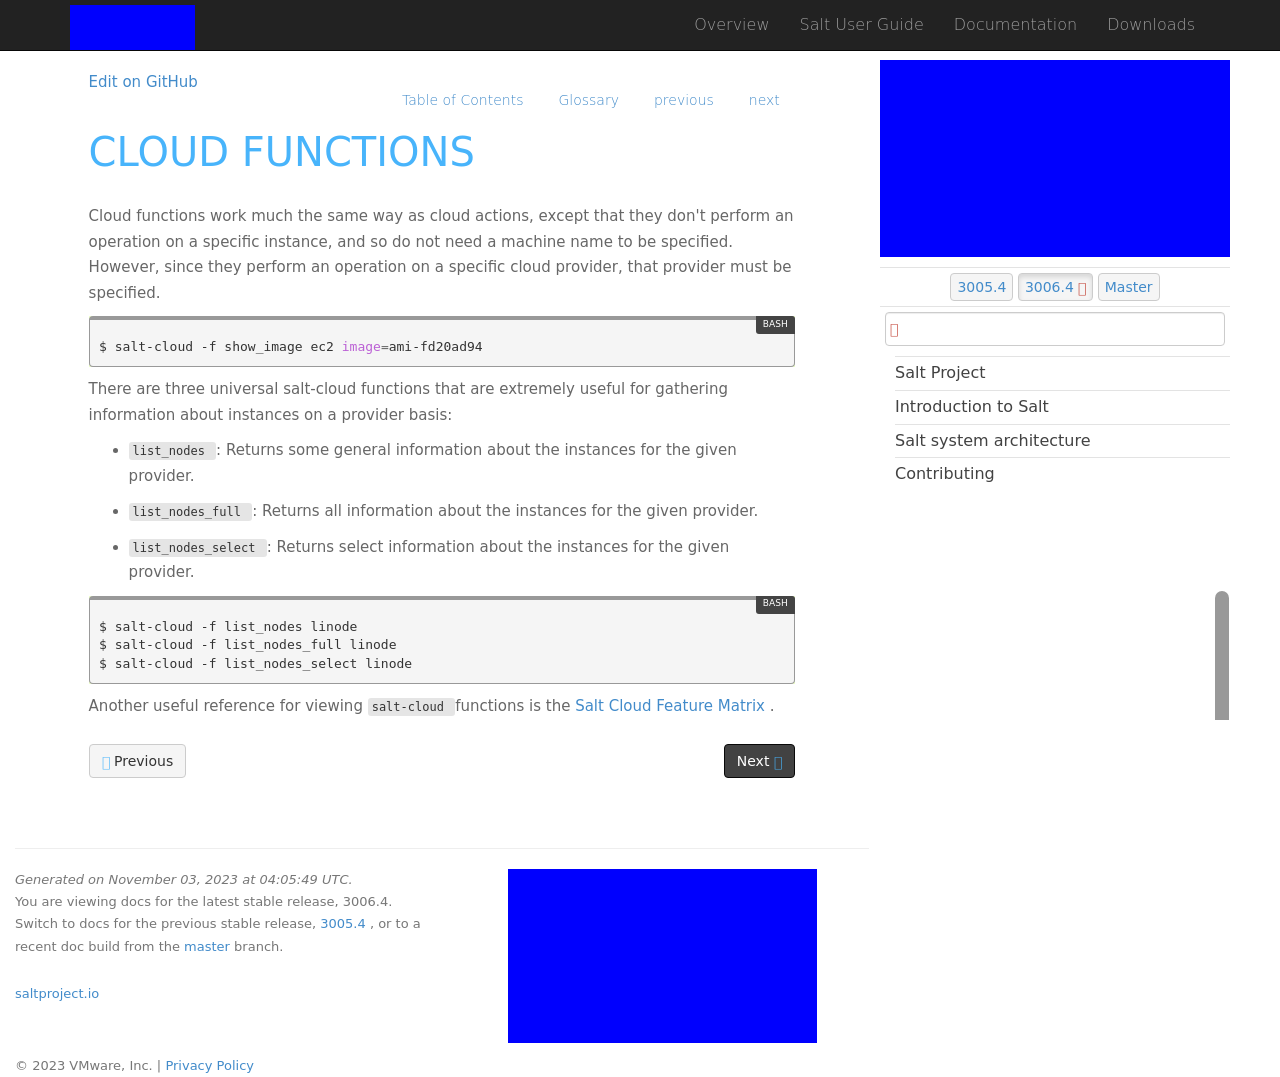How is the content of the website organized in terms of navigation and accessibility? The website content appears very organized, with a top navigation bar that includes links to various sections such as Overview, Salt User Guide, Documentation, and Downloads. Accessibility features are not distinctly visible from the image but typically include considerations for screen readers, appropriate color contrasts, and responsive design to adapt to different screen sizes and devices. 